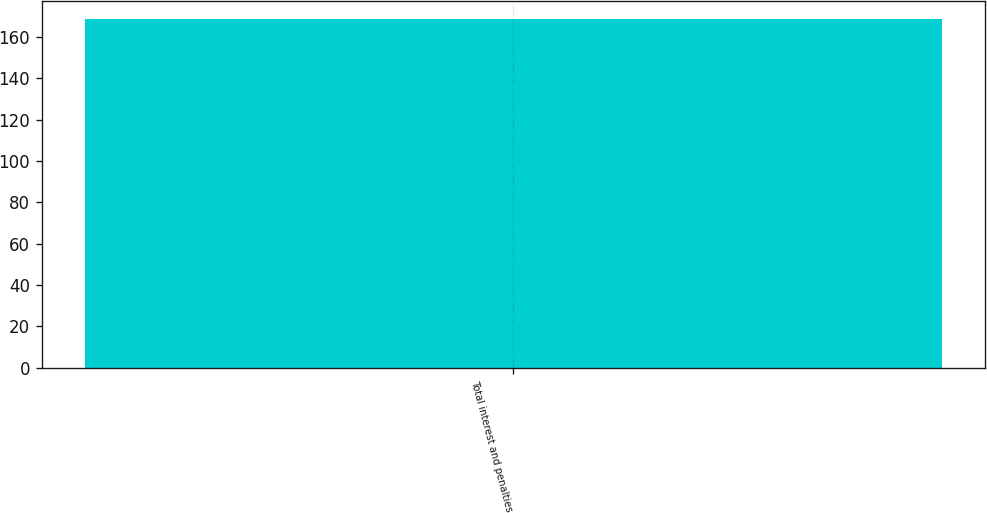Convert chart. <chart><loc_0><loc_0><loc_500><loc_500><bar_chart><fcel>Total interest and penalties<nl><fcel>169<nl></chart> 